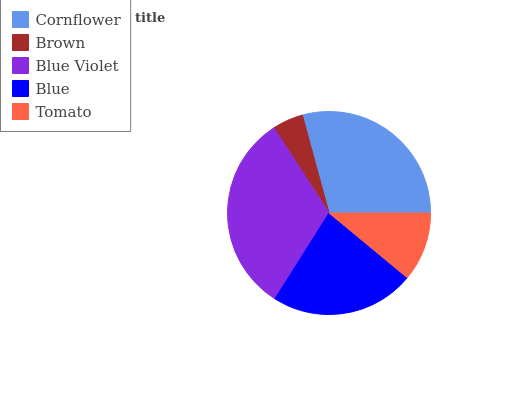Is Brown the minimum?
Answer yes or no. Yes. Is Blue Violet the maximum?
Answer yes or no. Yes. Is Blue Violet the minimum?
Answer yes or no. No. Is Brown the maximum?
Answer yes or no. No. Is Blue Violet greater than Brown?
Answer yes or no. Yes. Is Brown less than Blue Violet?
Answer yes or no. Yes. Is Brown greater than Blue Violet?
Answer yes or no. No. Is Blue Violet less than Brown?
Answer yes or no. No. Is Blue the high median?
Answer yes or no. Yes. Is Blue the low median?
Answer yes or no. Yes. Is Cornflower the high median?
Answer yes or no. No. Is Cornflower the low median?
Answer yes or no. No. 